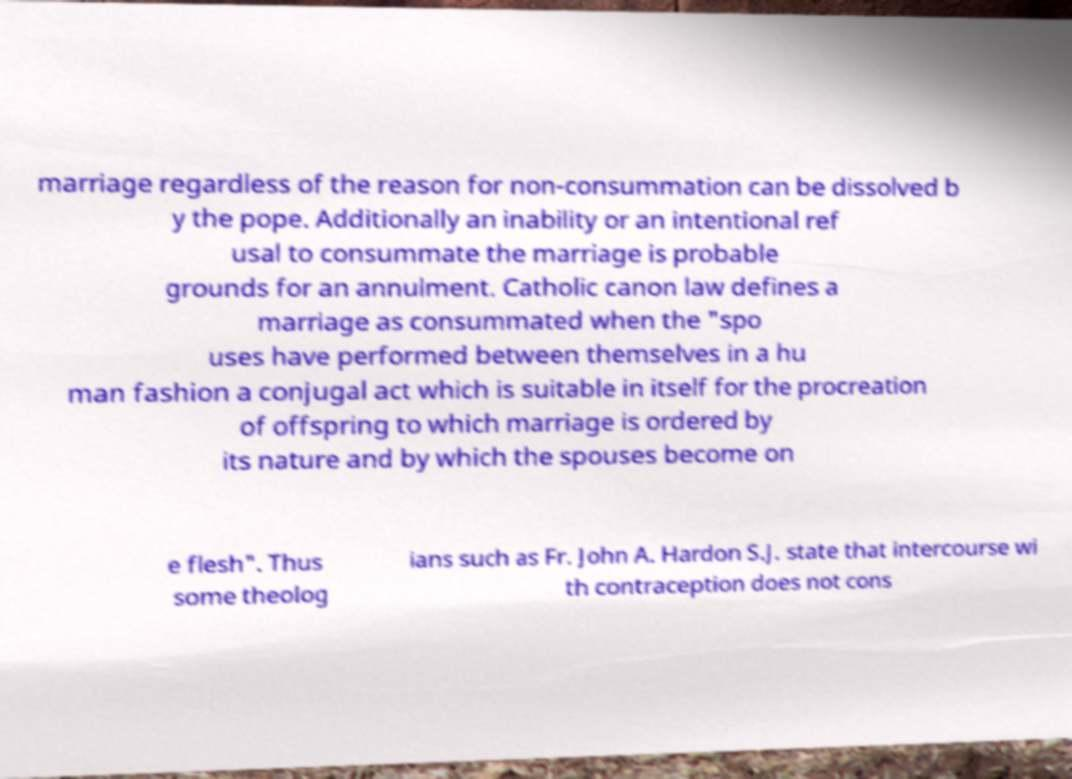Please identify and transcribe the text found in this image. marriage regardless of the reason for non-consummation can be dissolved b y the pope. Additionally an inability or an intentional ref usal to consummate the marriage is probable grounds for an annulment. Catholic canon law defines a marriage as consummated when the "spo uses have performed between themselves in a hu man fashion a conjugal act which is suitable in itself for the procreation of offspring to which marriage is ordered by its nature and by which the spouses become on e flesh". Thus some theolog ians such as Fr. John A. Hardon S.J. state that intercourse wi th contraception does not cons 